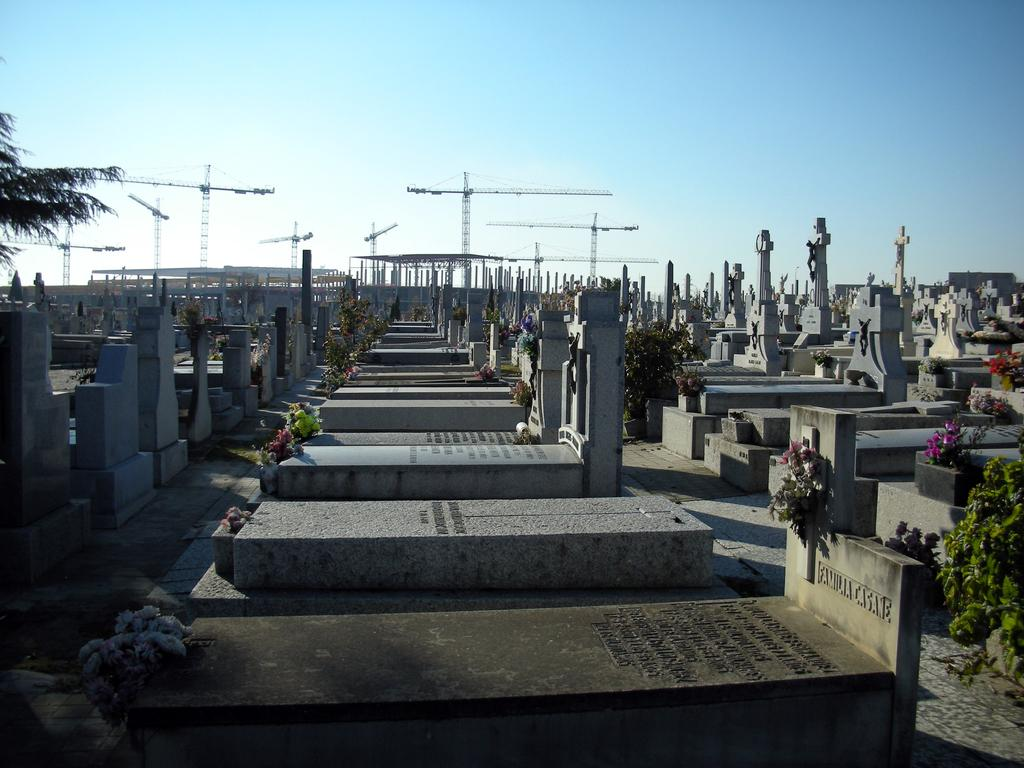What can be seen in the image? There are graves in the image, with books placed on them. What is visible in the background of the image? There are cranes and the sky visible in the background. Can you describe the tree in the image? There is a tree in the top left of the image. What type of chair is placed next to the graves in the image? There is no chair present in the image; it only features graves, books, cranes, the sky, and a tree. 